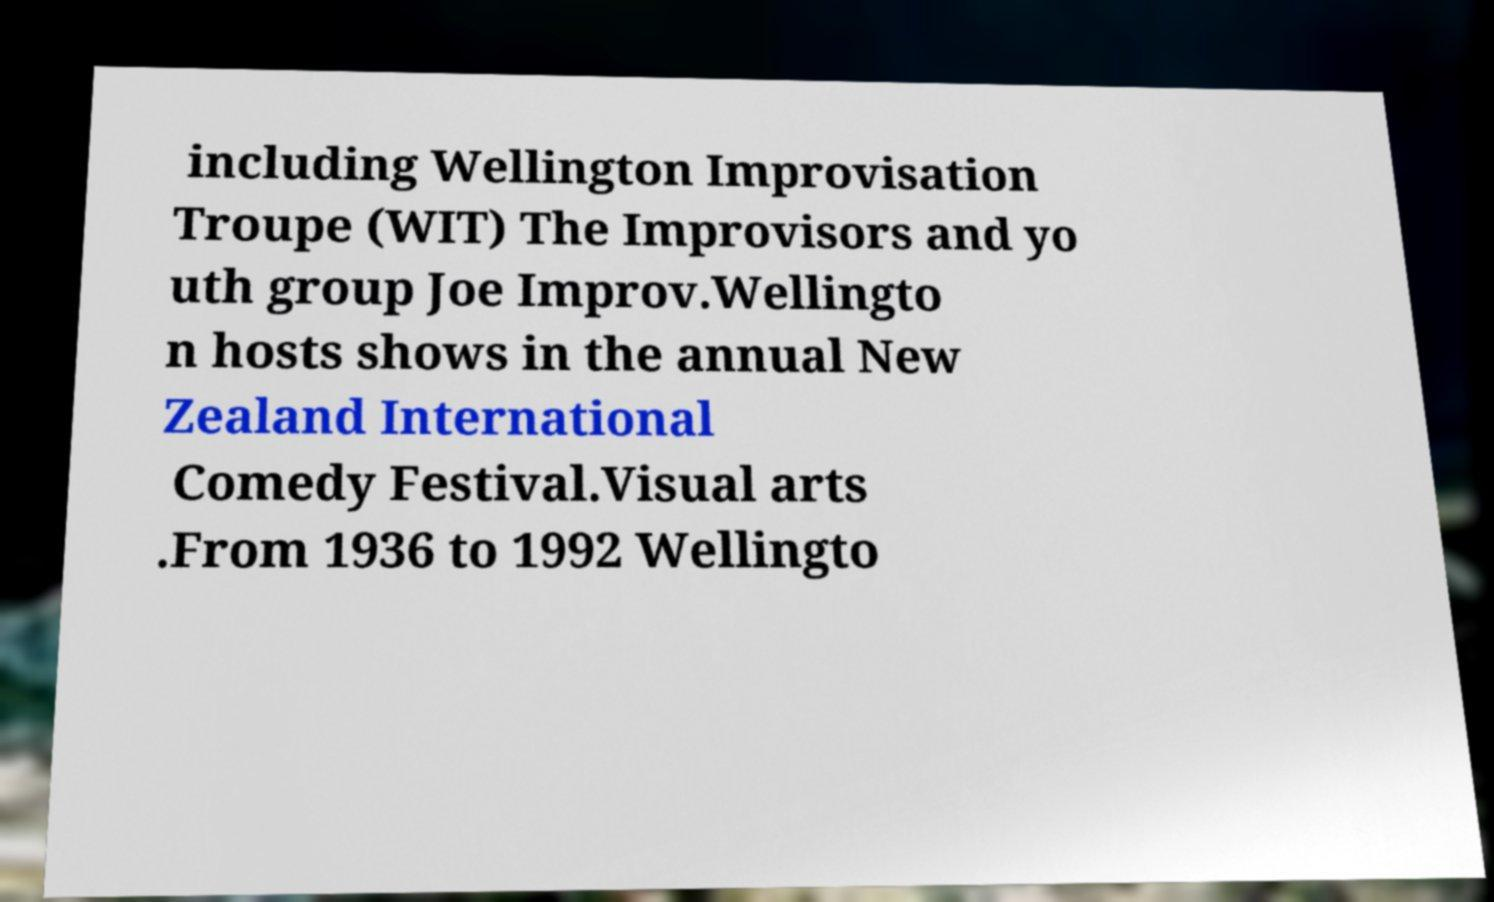Could you extract and type out the text from this image? including Wellington Improvisation Troupe (WIT) The Improvisors and yo uth group Joe Improv.Wellingto n hosts shows in the annual New Zealand International Comedy Festival.Visual arts .From 1936 to 1992 Wellingto 